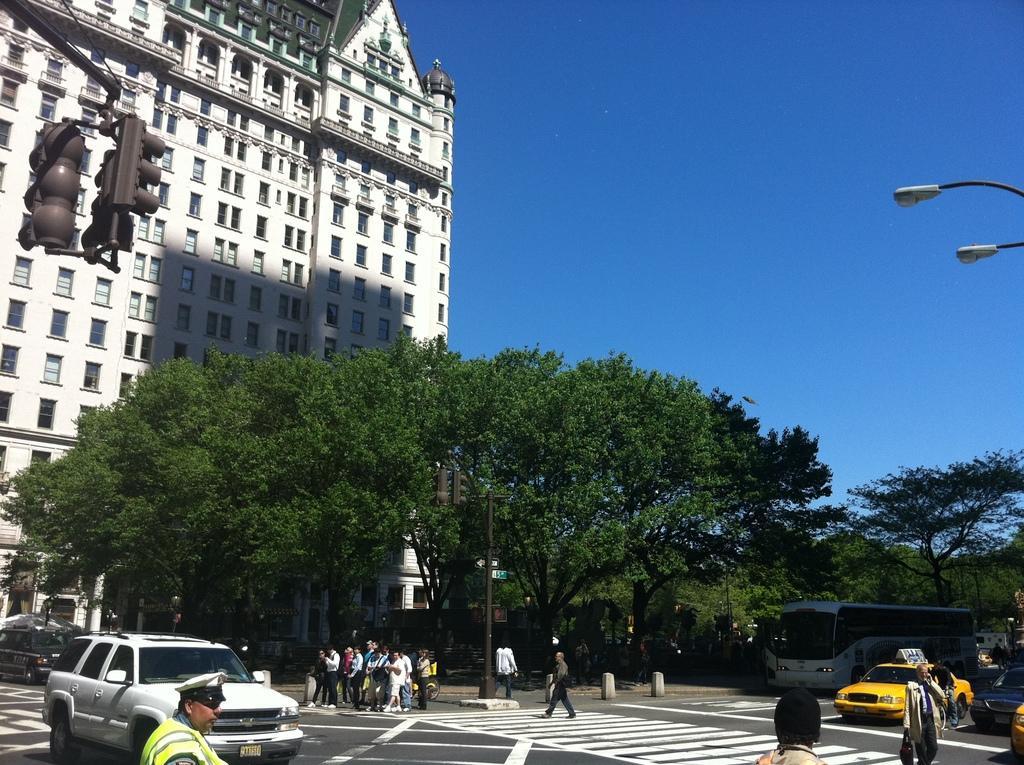Could you give a brief overview of what you see in this image? In this picture there are people and we can see vehicles on the road, poles, lights, traffic cones, boards, building and trees. In the background of the image we can see the sky in blue color. 